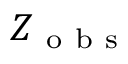<formula> <loc_0><loc_0><loc_500><loc_500>Z _ { o b s }</formula> 